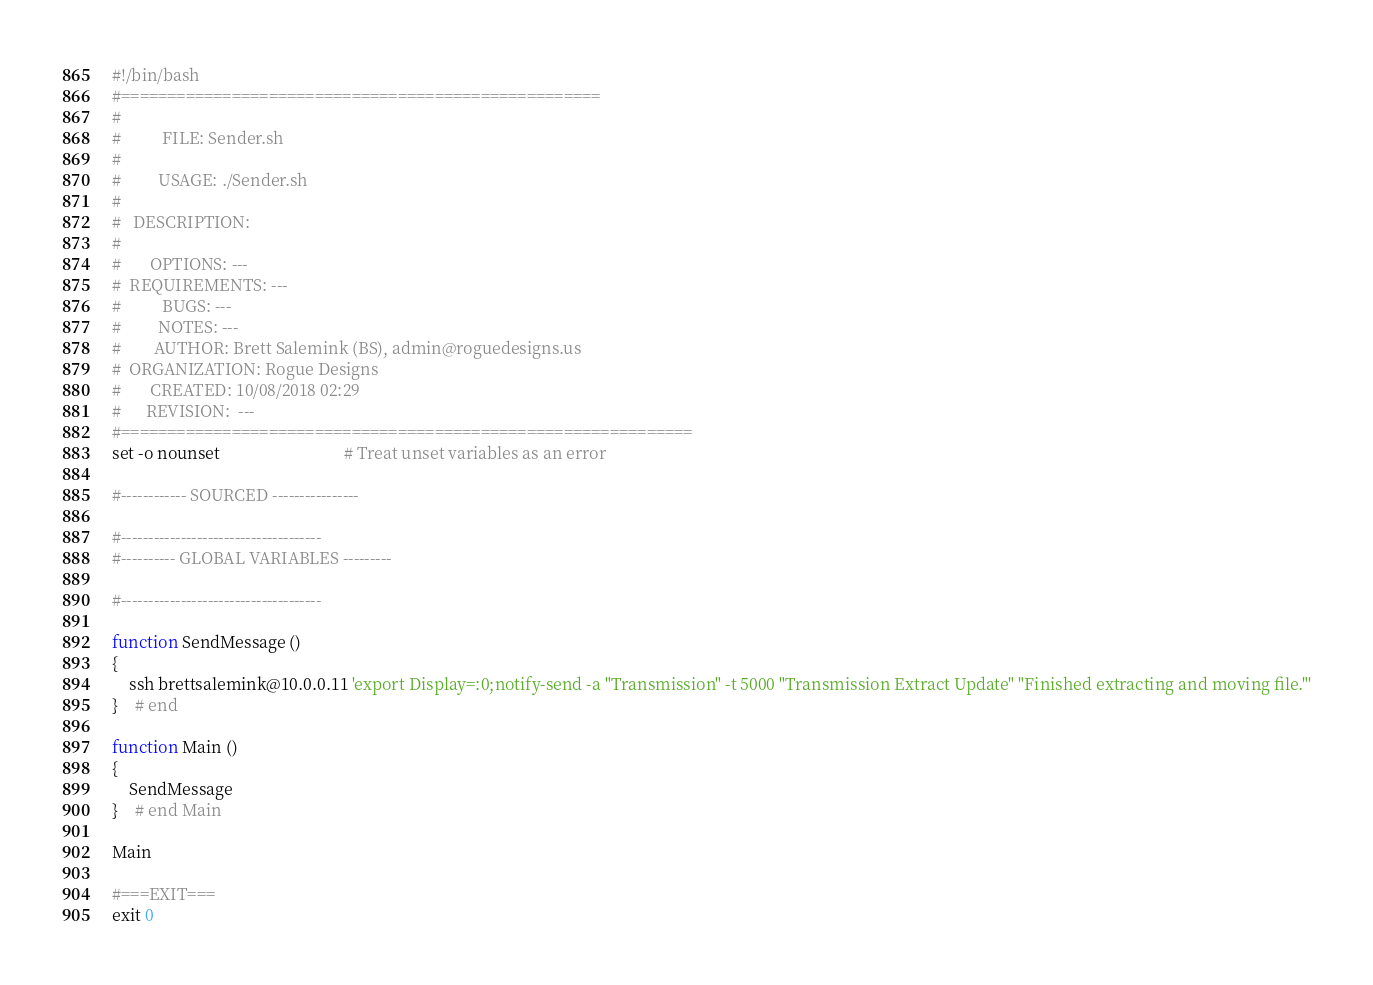<code> <loc_0><loc_0><loc_500><loc_500><_Bash_>#!/bin/bash  
#====================================================
#
#          FILE: Sender.sh
# 
#         USAGE: ./Sender.sh 
# 
#   DESCRIPTION: 
# 
#       OPTIONS: ---
#  REQUIREMENTS: ---
#          BUGS: ---
#         NOTES: ---
#        AUTHOR: Brett Salemink (BS), admin@roguedesigns.us
#  ORGANIZATION: Rogue Designs
#       CREATED: 10/08/2018 02:29
#      REVISION:  ---
#==============================================================
set -o nounset                              # Treat unset variables as an error

#------------ SOURCED ----------------

#-------------------------------------
#---------- GLOBAL VARIABLES ---------

#-------------------------------------

function SendMessage ()
{
	ssh brettsalemink@10.0.0.11 'export Display=:0;notify-send -a "Transmission" -t 5000 "Transmission Extract Update" "Finished extracting and moving file."'
}	# end

function Main ()
{
	SendMessage
}	# end Main

Main

#===EXIT===
exit 0

</code> 